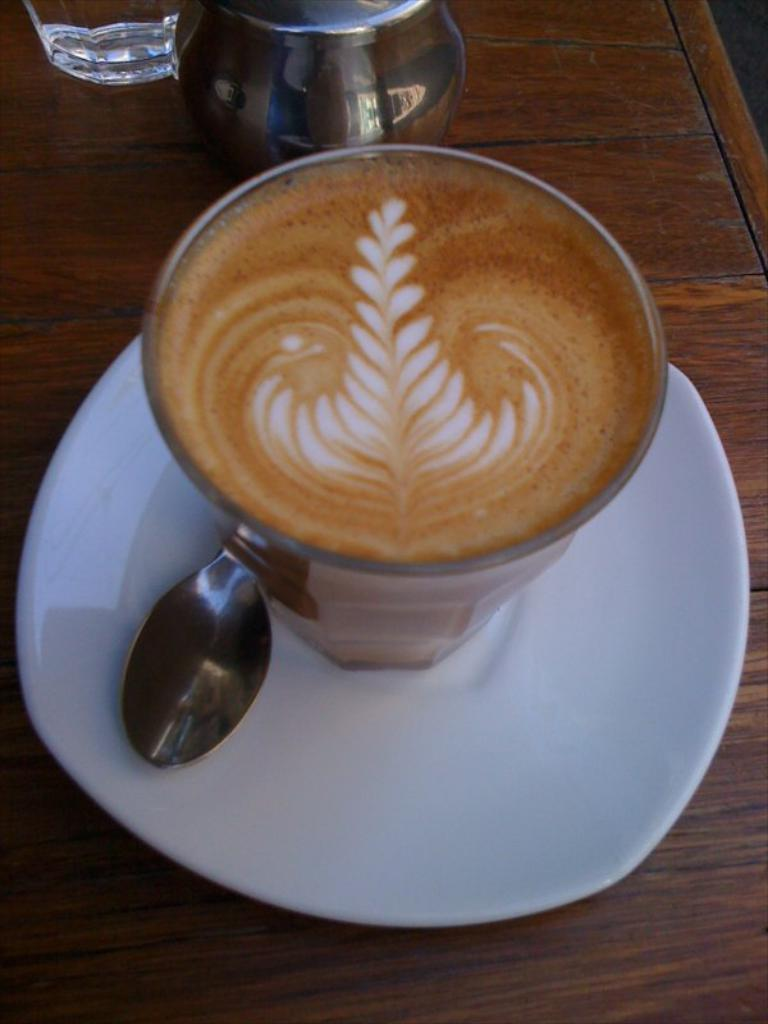What is present on the table in the image? There is a cup, a spoon in the saucer, a glass, and a jug on the table in the image. Can you describe the utensil in the saucer? There is a spoon in the saucer in the image. What is located beside the cup? There is a glass beside the cup in the image. What container is on the table for holding liquids? There is a jug on the table in the image. Can you tell me how many robins are sitting on the jug in the image? There are no robins present in the image; it only features a cup, spoon in the saucer, glass, and jug on the table. What type of pump is connected to the glass in the image? There is no pump connected to the glass in the image; it is simply a glass beside the cup. 